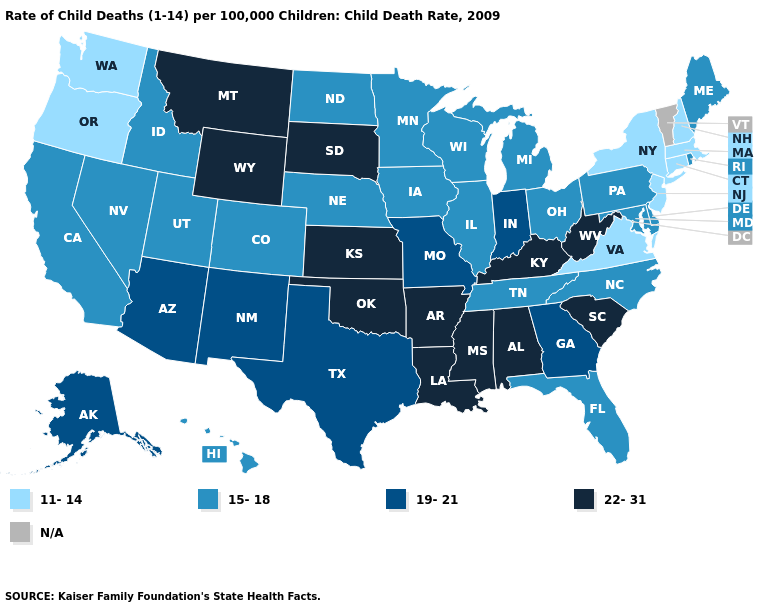Name the states that have a value in the range N/A?
Keep it brief. Vermont. Name the states that have a value in the range 19-21?
Concise answer only. Alaska, Arizona, Georgia, Indiana, Missouri, New Mexico, Texas. Which states have the lowest value in the USA?
Give a very brief answer. Connecticut, Massachusetts, New Hampshire, New Jersey, New York, Oregon, Virginia, Washington. Does West Virginia have the highest value in the USA?
Be succinct. Yes. Does Maryland have the highest value in the USA?
Answer briefly. No. Name the states that have a value in the range 15-18?
Write a very short answer. California, Colorado, Delaware, Florida, Hawaii, Idaho, Illinois, Iowa, Maine, Maryland, Michigan, Minnesota, Nebraska, Nevada, North Carolina, North Dakota, Ohio, Pennsylvania, Rhode Island, Tennessee, Utah, Wisconsin. Which states have the lowest value in the USA?
Be succinct. Connecticut, Massachusetts, New Hampshire, New Jersey, New York, Oregon, Virginia, Washington. Does the first symbol in the legend represent the smallest category?
Give a very brief answer. Yes. What is the value of Michigan?
Quick response, please. 15-18. What is the highest value in the USA?
Give a very brief answer. 22-31. Does Missouri have the lowest value in the MidWest?
Write a very short answer. No. Which states have the lowest value in the USA?
Give a very brief answer. Connecticut, Massachusetts, New Hampshire, New Jersey, New York, Oregon, Virginia, Washington. What is the lowest value in the South?
Quick response, please. 11-14. 